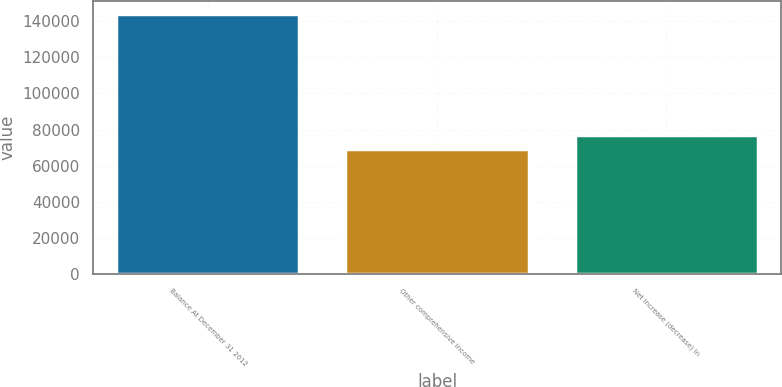Convert chart to OTSL. <chart><loc_0><loc_0><loc_500><loc_500><bar_chart><fcel>Balance At December 31 2012<fcel>Other comprehensive income<fcel>Net increase (decrease) in<nl><fcel>144200<fcel>69388<fcel>76869.2<nl></chart> 